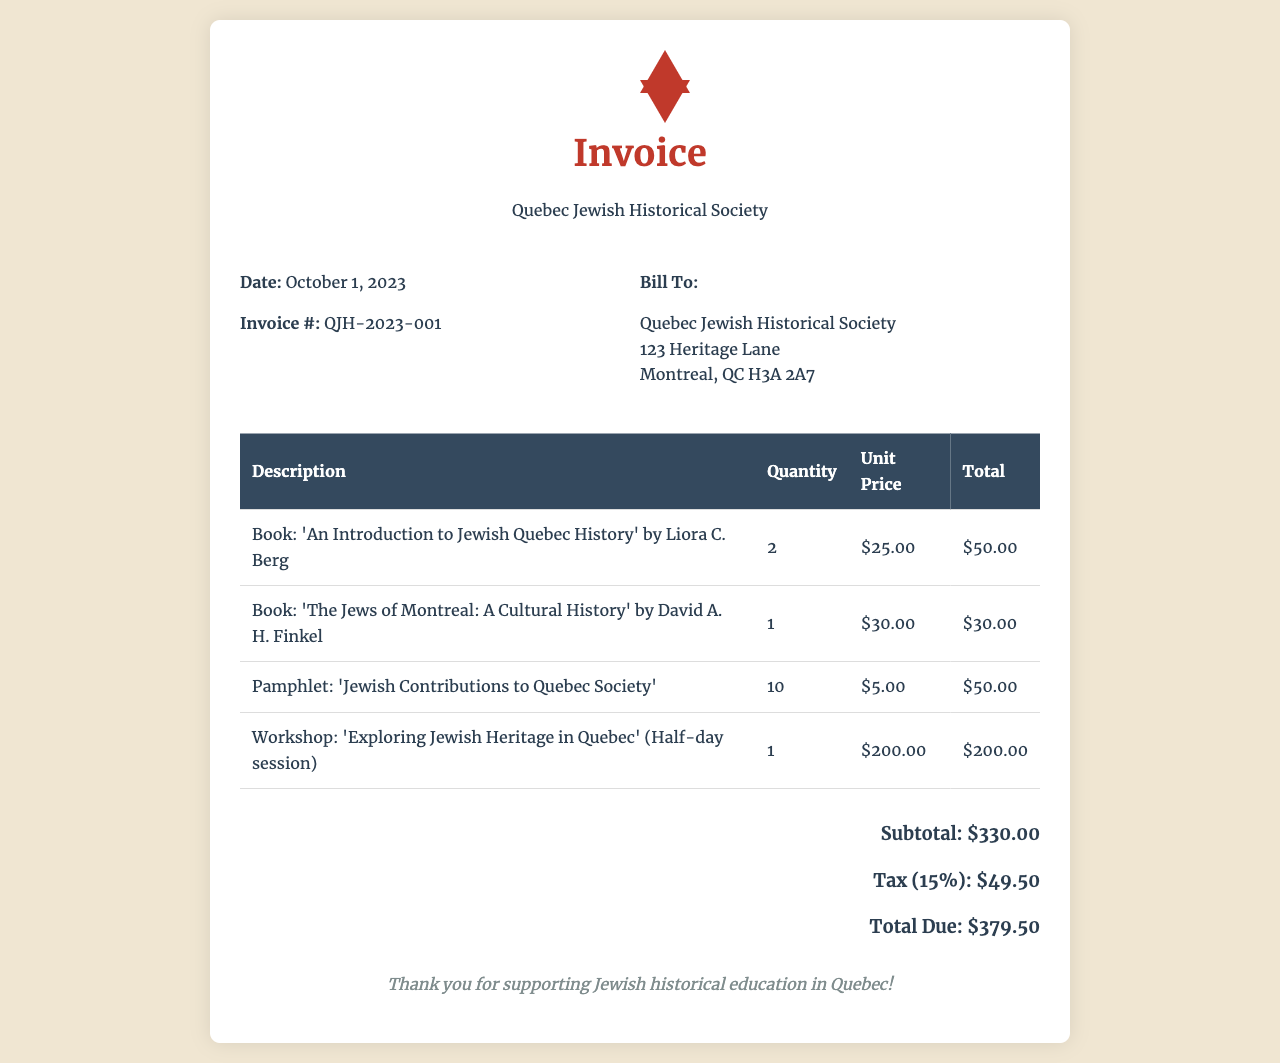what is the date of the invoice? The date of the invoice is specified in the document.
Answer: October 1, 2023 what is the total due amount? The total due is calculated with the subtotal and tax given.
Answer: $379.50 how many pamphlets were ordered? The quantity of pamphlets is listed in the invoice details.
Answer: 10 who is the author of 'An Introduction to Jewish Quebec History'? The document states the author of the book.
Answer: Liora C. Berg what percentage is the tax on the subtotal? The tax amount is provided in the document as a percentage of the subtotal.
Answer: 15% how many total books are listed in the invoice? To find this, we sum the quantities of books noted in the invoice.
Answer: 3 what is the unit price of the workshop? The unit price of the workshop is clearly listed in the document.
Answer: $200.00 what is the subtotal before tax? The subtotal is clearly indicated in the total section of the invoice.
Answer: $330.00 what is the invoice number? The unique identifier for the invoice appears in the invoice details.
Answer: QJH-2023-001 